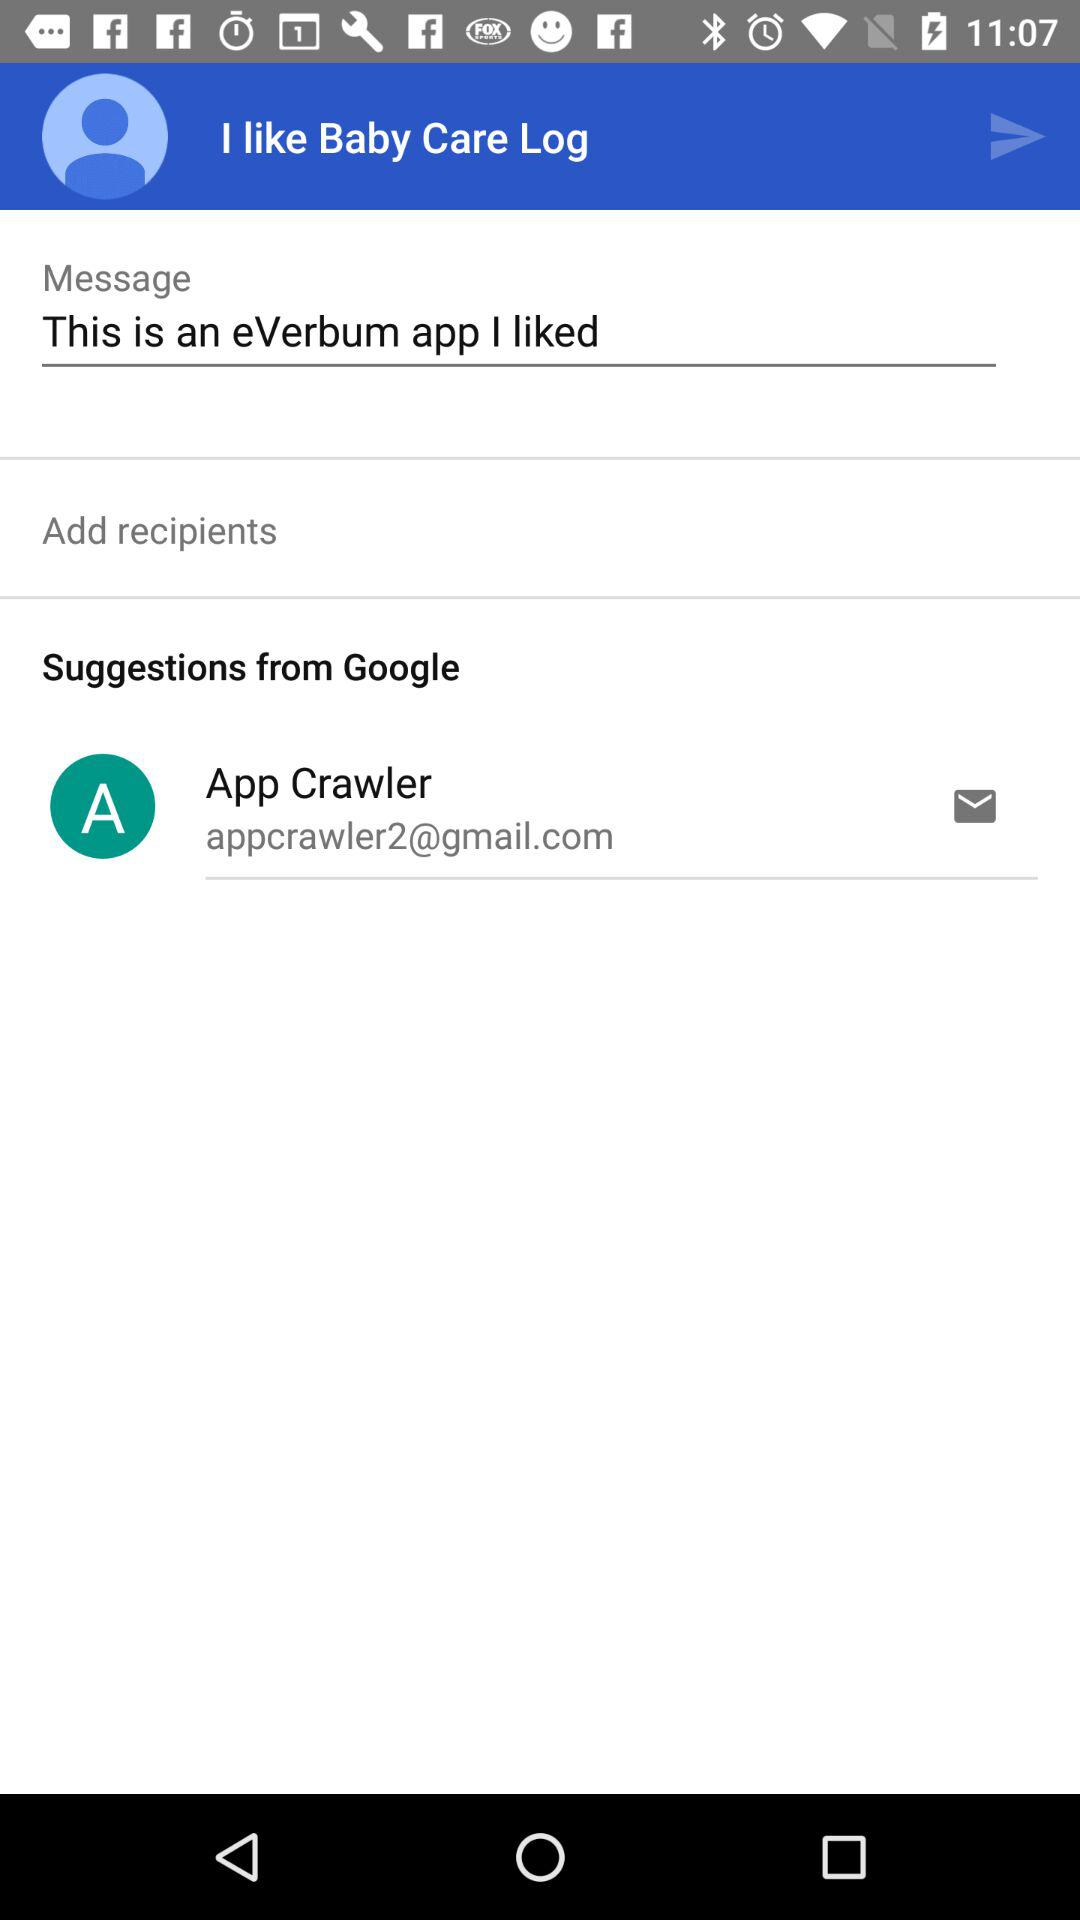What is the email address? The email address is appcrawler2@gmail.com. 